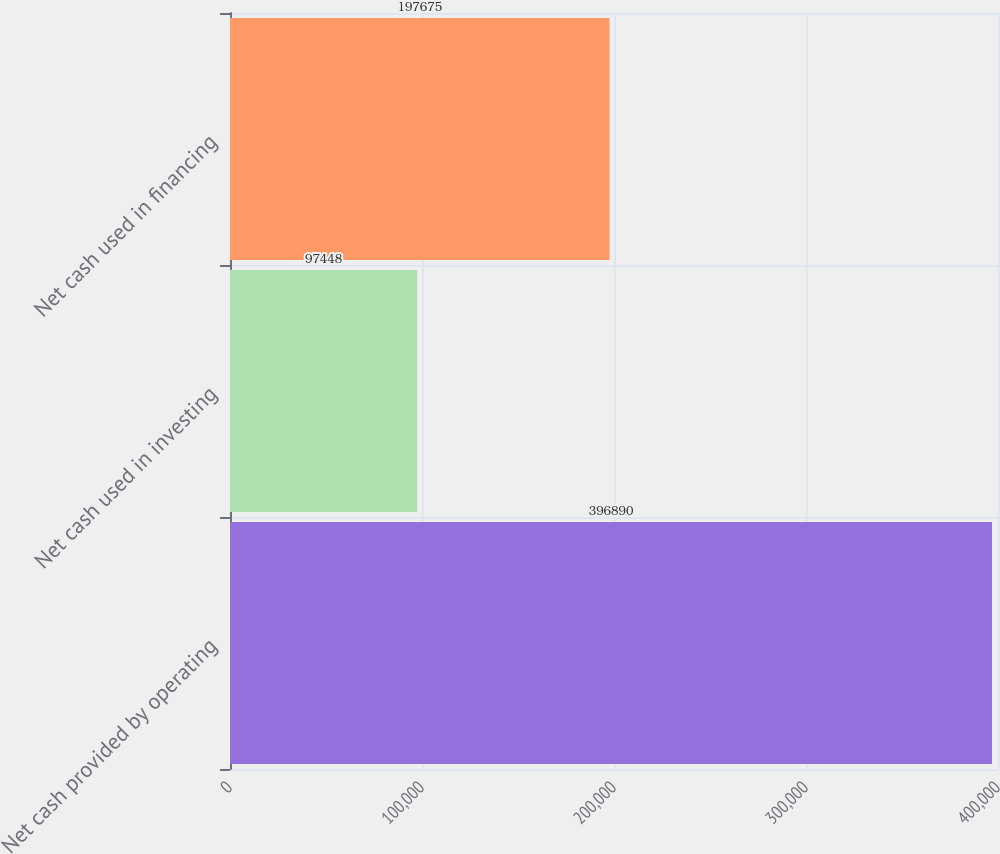Convert chart. <chart><loc_0><loc_0><loc_500><loc_500><bar_chart><fcel>Net cash provided by operating<fcel>Net cash used in investing<fcel>Net cash used in financing<nl><fcel>396890<fcel>97448<fcel>197675<nl></chart> 